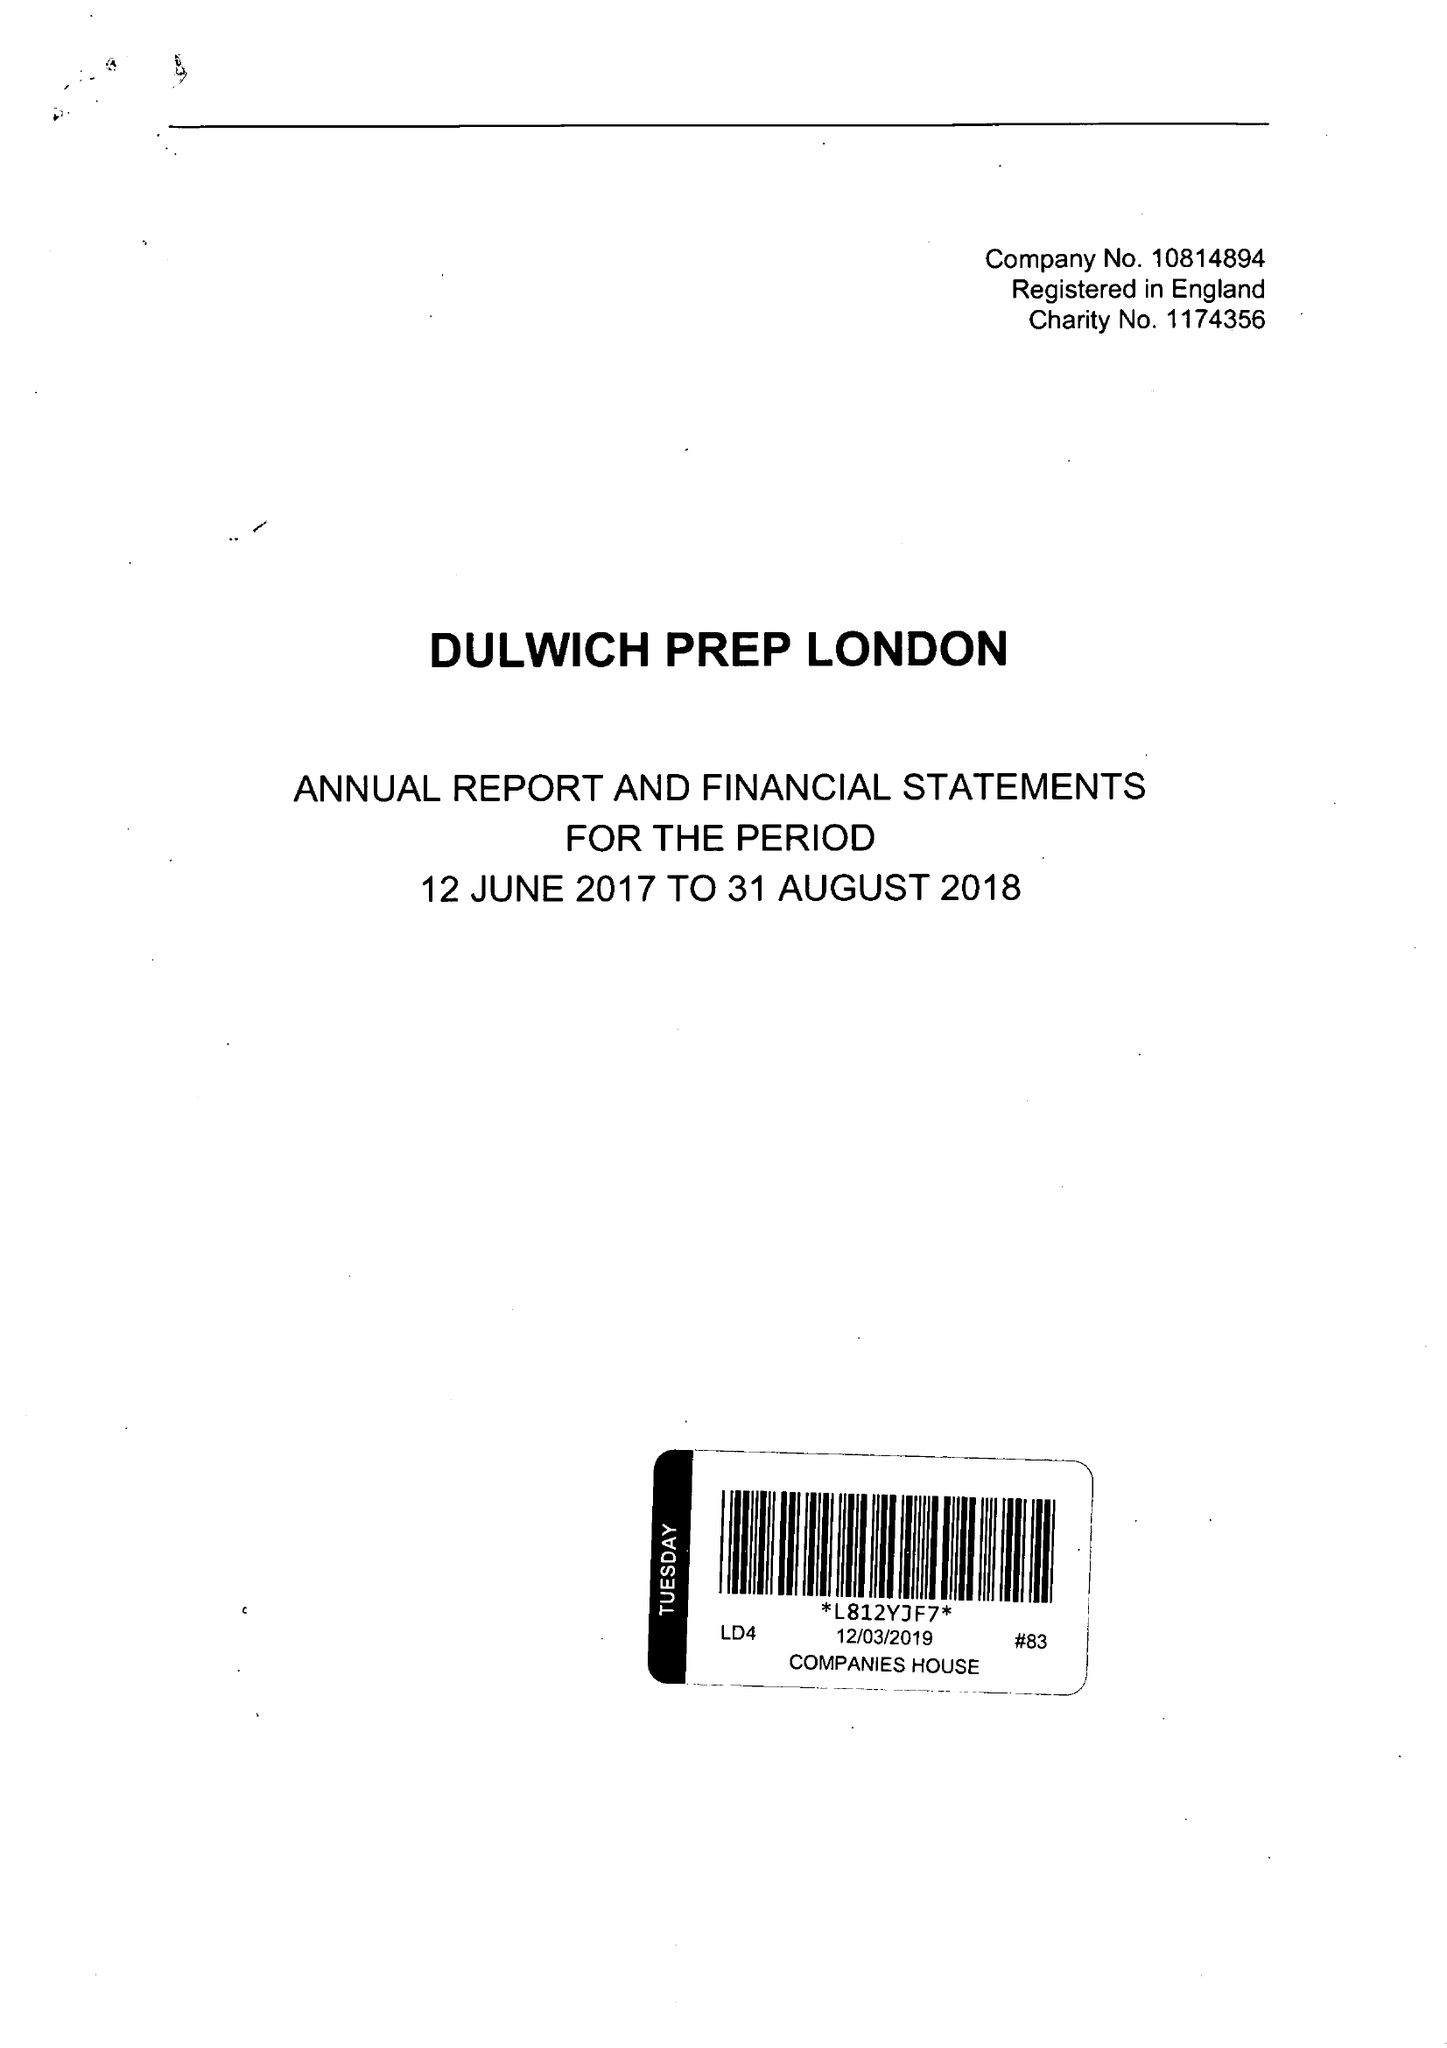What is the value for the income_annually_in_british_pounds?
Answer the question using a single word or phrase. 15739427.00 